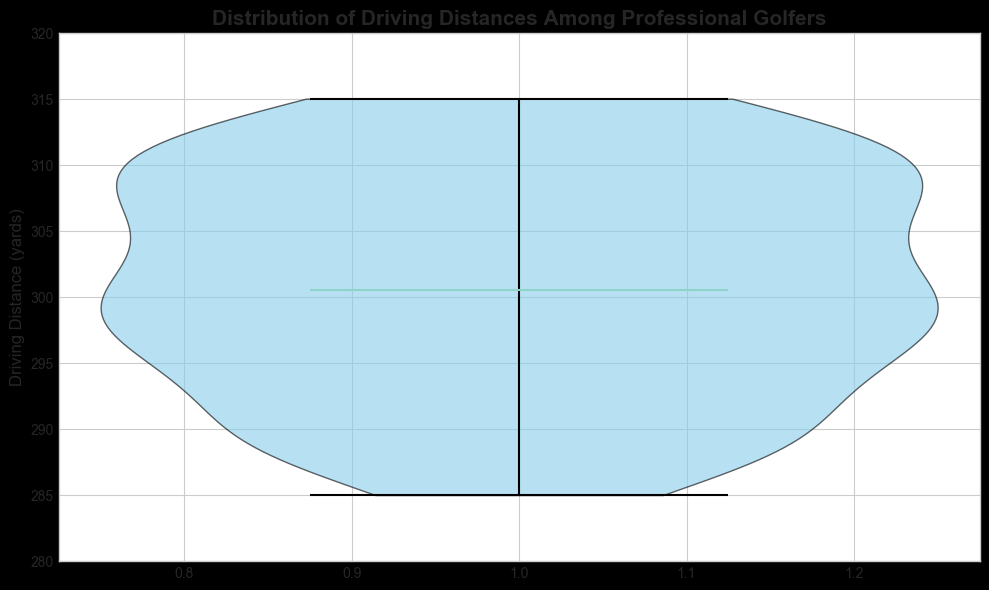What is the main feature of the violin plot? The main feature of the violin plot is to display the distribution of driving distances among professional golfers, with the shape indicating the density and the median indicated by a line.
Answer: Distribution of driving distances What is the median driving distance in the plot? The violin plot shows a line at the median value, which is the central point of the distribution.
Answer: Around 300 yards Is there a higher density of driving distances closer to 300 yards or 310 yards? The width of the violin plot is wider near 300 yards compared to 310 yards, indicating a higher density of data points around 300 yards.
Answer: 300 yards How does the variation in driving distances appear visually in the plot? The width of the violin plot at different driving distances shows higher variation as the plot widens and narrows.
Answer: Wider at the median, narrower at extremes What is the approximate range of driving distances displayed on the violin plot? The plot's y-axis ranges from 280 to 320 yards, indicating the approximate range of driving distances.
Answer: 280 to 320 yards How does the appearance of the median line help in understanding the distribution? The median line helps indicate the center of the distribution, where 50% of the data points lie below and above this line.
Answer: It indicates the center Which driving distance appears to have the lowest density in the plot? The narrower sections of the plot suggest lower density, which appears to be around 280 yards.
Answer: 280 yards Is the distribution of driving distances symmetric? By observing the symmetry of the violin plot around the median line, it can be inferred whether the distribution is symmetric or skewed.
Answer: Symmetric Comparing the density around 290 yards and 310 yards, which is higher? The violin plot's width indicates density; 290 yards has a narrower section compared to 310 yards.
Answer: 310 yards What visual feature helps to distinguish the density of driving distances? The width of the violin plot indicates density, with wider sections representing higher densities, and the plot uses a specific color to help identify these areas.
Answer: Plot width 